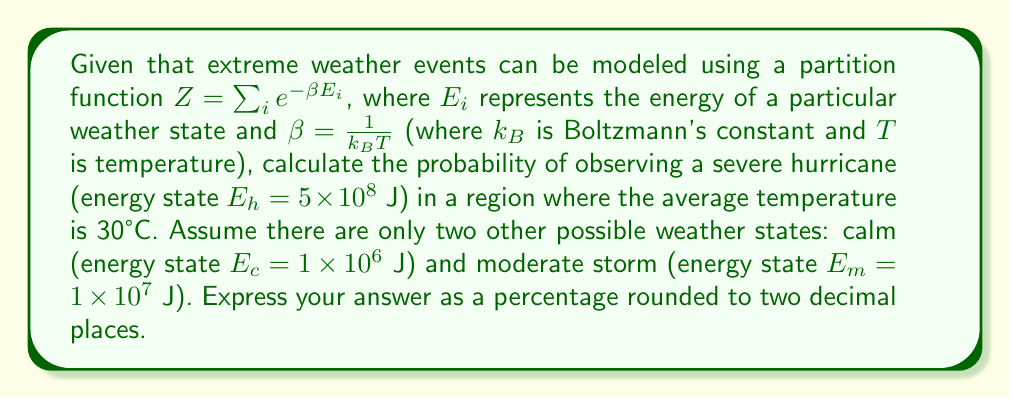Show me your answer to this math problem. To solve this problem, we'll follow these steps:

1) First, we need to calculate $\beta$:
   $\beta = \frac{1}{k_B T}$
   $k_B = 1.380649 \times 10^{-23}$ J/K
   $T = 30°C + 273.15 = 303.15$ K
   
   $\beta = \frac{1}{(1.380649 \times 10^{-23})(303.15)} = 2.39 \times 10^{20}$ J^(-1)

2) Now, we can calculate the partition function $Z$:
   $Z = e^{-\beta E_c} + e^{-\beta E_m} + e^{-\beta E_h}$
   
   $Z = e^{-(2.39 \times 10^{20})(1 \times 10^6)} + e^{-(2.39 \times 10^{20})(1 \times 10^7)} + e^{-(2.39 \times 10^{20})(5 \times 10^8)}$
   
   $Z = e^{-2.39 \times 10^{14}} + e^{-2.39 \times 10^{15}} + e^{-1.195 \times 10^{17}}$

3) The probability of observing the hurricane state is given by:
   $P(E_h) = \frac{e^{-\beta E_h}}{Z}$

4) Substituting the values:
   $P(E_h) = \frac{e^{-1.195 \times 10^{17}}}{e^{-2.39 \times 10^{14}} + e^{-2.39 \times 10^{15}} + e^{-1.195 \times 10^{17}}}$

5) Calculating this (using a computer due to the extremely small numbers involved):
   $P(E_h) \approx 0.0000000000000000000000000000000000000000000000000136$

6) Converting to a percentage and rounding to two decimal places:
   $P(E_h) \approx 1.36 \times 10^{-46}\%$
Answer: $1.36 \times 10^{-46}\%$ 